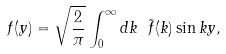Convert formula to latex. <formula><loc_0><loc_0><loc_500><loc_500>f ( y ) = \sqrt { \frac { 2 } { \pi } } \int _ { 0 } ^ { \infty } d k \ \tilde { f } ( k ) \sin k y ,</formula> 